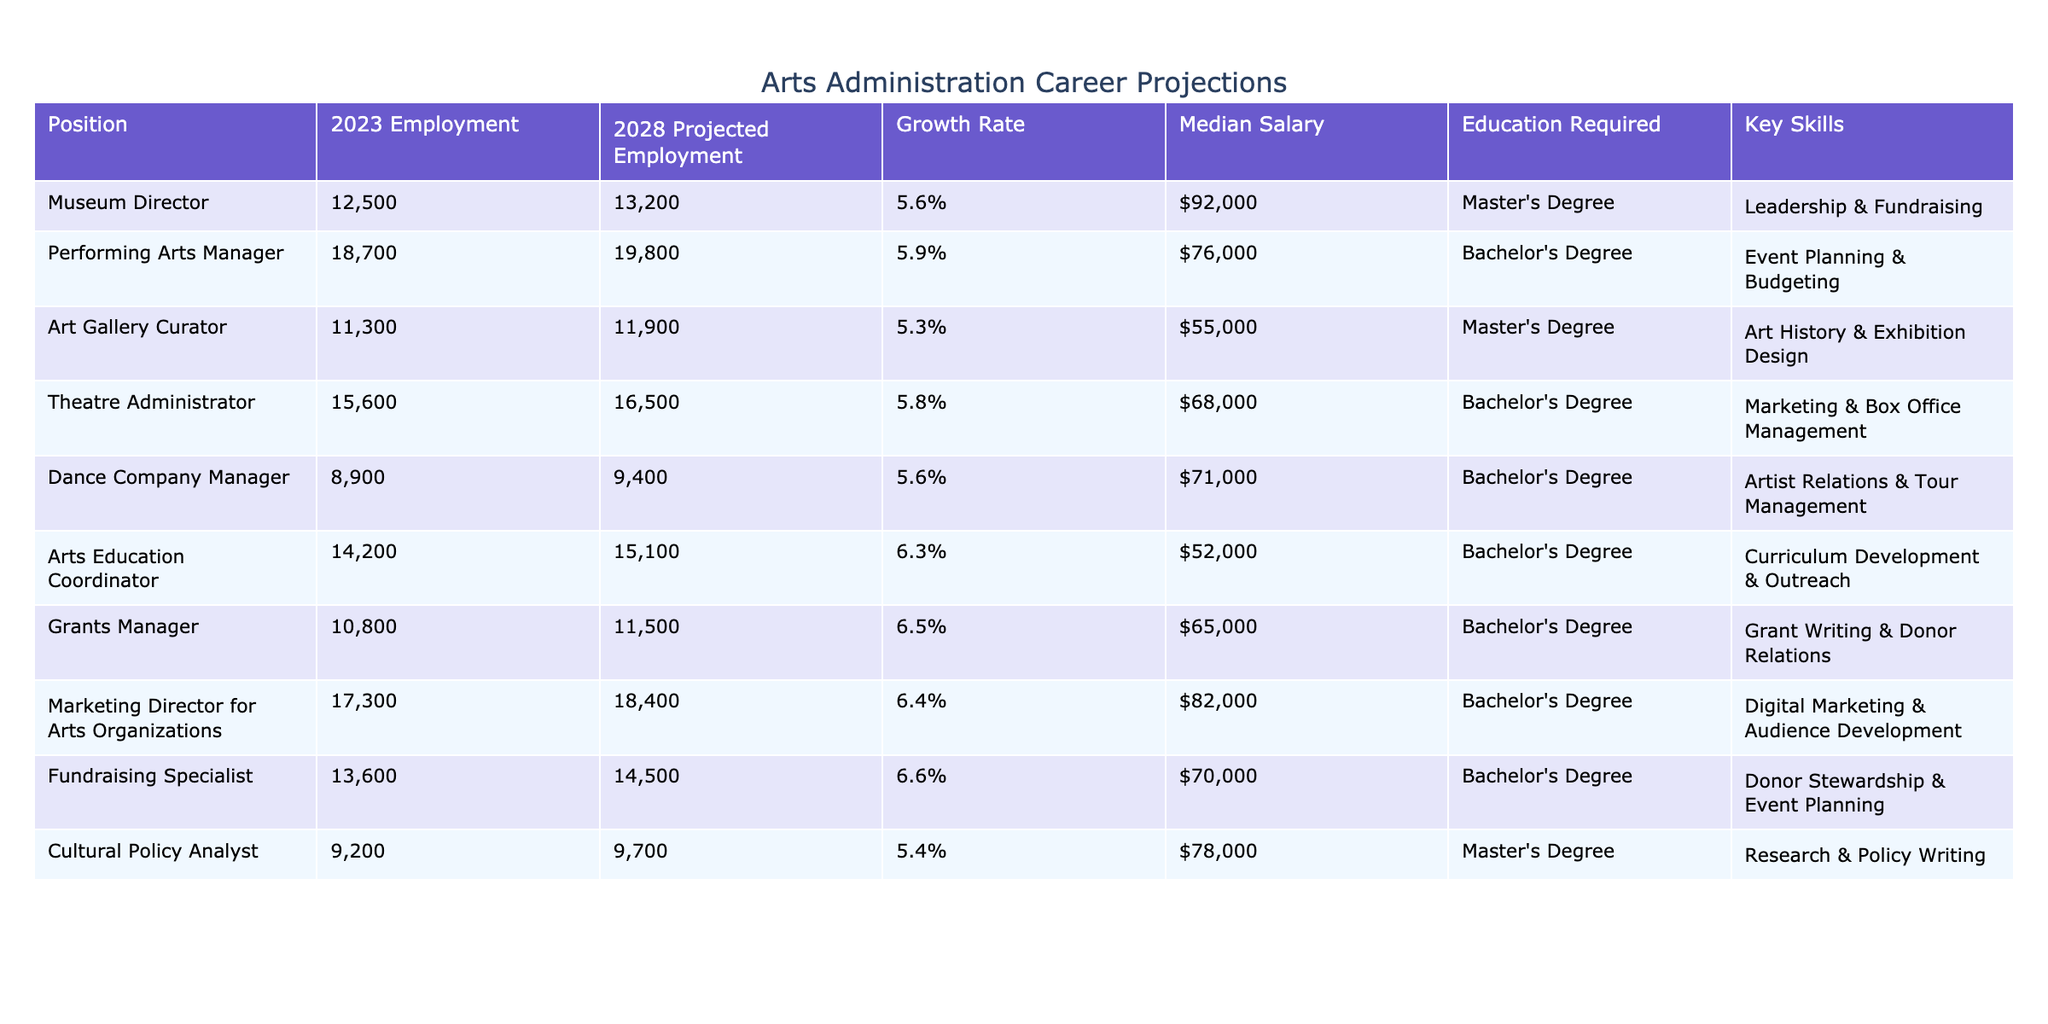What is the projected employment for Arts Education Coordinators in 2028? The table shows that the projected employment for Arts Education Coordinators in 2028 is 15,100.
Answer: 15,100 Which position has the highest median salary? By comparing the median salaries listed, the Museum Director has the highest median salary at $92,000.
Answer: Museum Director What is the average growth rate for the positions listed? The growth rates for all positions are: 5.6%, 5.9%, 5.3%, 5.8%, 5.6%, 6.3%, 6.5%, 6.4%, 6.6%, and 5.4%. Adding these yields a sum of 59.6%. Dividing by the number of positions (10) gives an average growth rate of 5.96%.
Answer: 5.96% Is the growth rate for the Performing Arts Manager position higher than the growth rate for the Dance Company Manager position? The growth rate for the Performing Arts Manager is 5.9%, while the growth rate for the Dance Company Manager is 5.6%. Since 5.9% is greater than 5.6%, the answer is yes.
Answer: Yes What is the difference in median salaries between the Marketing Director for Arts Organizations and the Theatre Administrator? The median salary for the Marketing Director is $82,000 and for the Theatre Administrator, it is $68,000. The difference is calculated as 82,000 - 68,000 = 14,000.
Answer: $14,000 Which roles require a Master's Degree? According to the table, the positions that require a Master's Degree are Museum Director, Art Gallery Curator, and Cultural Policy Analyst.
Answer: Museum Director, Art Gallery Curator, Cultural Policy Analyst Which position has the lowest projected employment in 2028, and what is that number? The position with the lowest projected employment in 2028 is the Dance Company Manager, with a number of 9,400.
Answer: 9,400 If the median salary of the Funds Manager increases by 10%, what will be the new salary? The current median salary for the Grants Manager is $65,000. An increase of 10% is calculated as 65,000 * 0.10 = 6,500. Therefore, the new salary will be 65,000 + 6,500 = 71,500.
Answer: $71,500 Are there more positions with projected employment over 15,000 or under 15,000 in 2028? By reviewing the table, there are positions with projected employment over 15,000 (Museum Director, Performing Arts Manager, Theatre Administrator, and Marketing Director for Arts Organizations) totaling 4, whereas those under 15,000 (Art Gallery Curator, Dance Company Manager, Arts Education Coordinator, Grants Manager, Fundraising Specialist, and Cultural Policy Analyst) total 6. Thus, there are more positions under 15,000.
Answer: Under 15,000 What is the ratio of the highest median salary to the lowest median salary? The highest median salary is $92,000 (Museum Director) and the lowest is $55,000 (Art Gallery Curator). Calculating the ratio gives 92,000 / 55,000 = 1.673, which simplifies to approximately 1.67 when expressed in simplest terms.
Answer: 1.67 